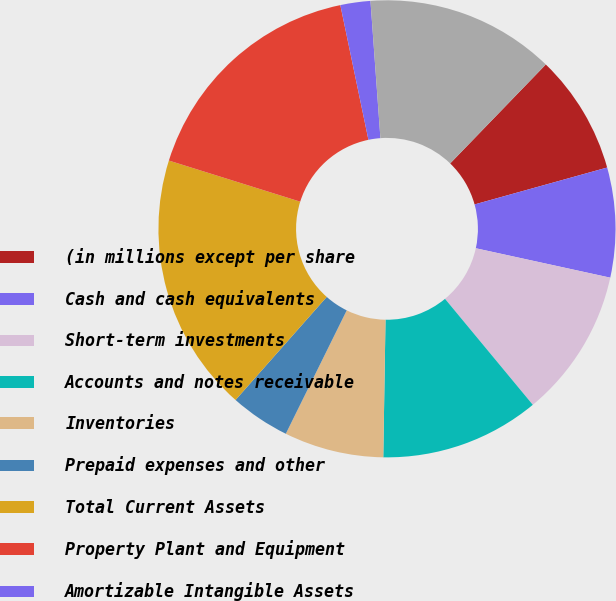Convert chart to OTSL. <chart><loc_0><loc_0><loc_500><loc_500><pie_chart><fcel>(in millions except per share<fcel>Cash and cash equivalents<fcel>Short-term investments<fcel>Accounts and notes receivable<fcel>Inventories<fcel>Prepaid expenses and other<fcel>Total Current Assets<fcel>Property Plant and Equipment<fcel>Amortizable Intangible Assets<fcel>Goodwill<nl><fcel>8.45%<fcel>7.75%<fcel>10.56%<fcel>11.27%<fcel>7.04%<fcel>4.23%<fcel>18.3%<fcel>16.9%<fcel>2.12%<fcel>13.38%<nl></chart> 